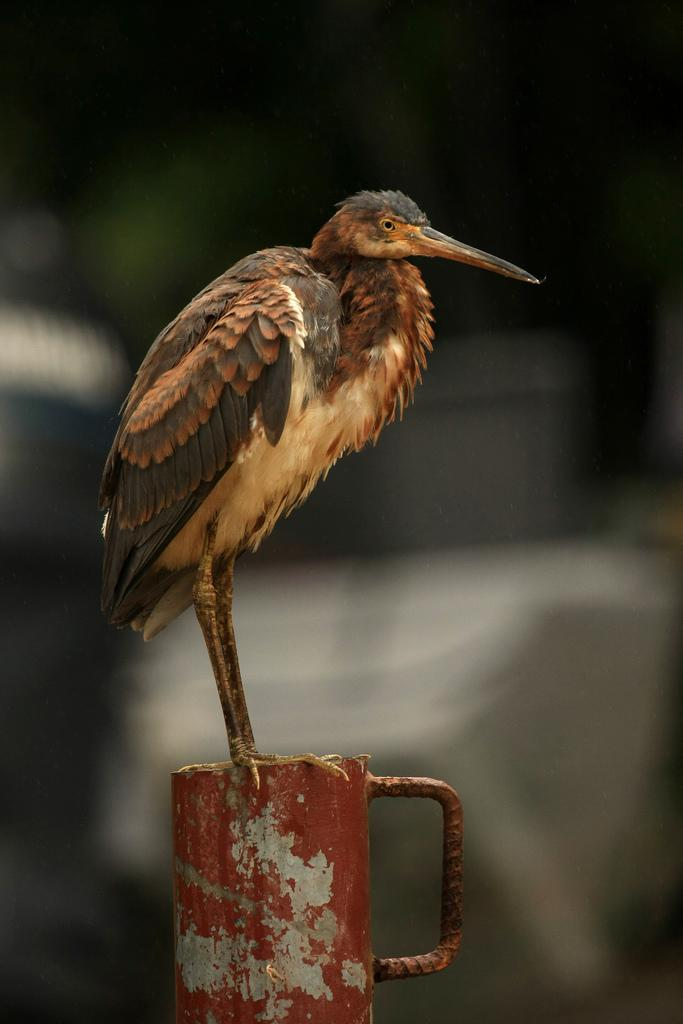What type of animal is in the image? There is a bird in the image. Where is the bird located? The bird is on a rod. Can you describe the background of the image? The background of the image is blurred. What type of rabbits are participating in the feast in the image? There are no rabbits or feast present in the image; it features a bird on a rod with a blurred background. What type of support is the bird using to stay on the rod? The bird's feet and the rod itself provide the support for the bird to stay on the rod. 